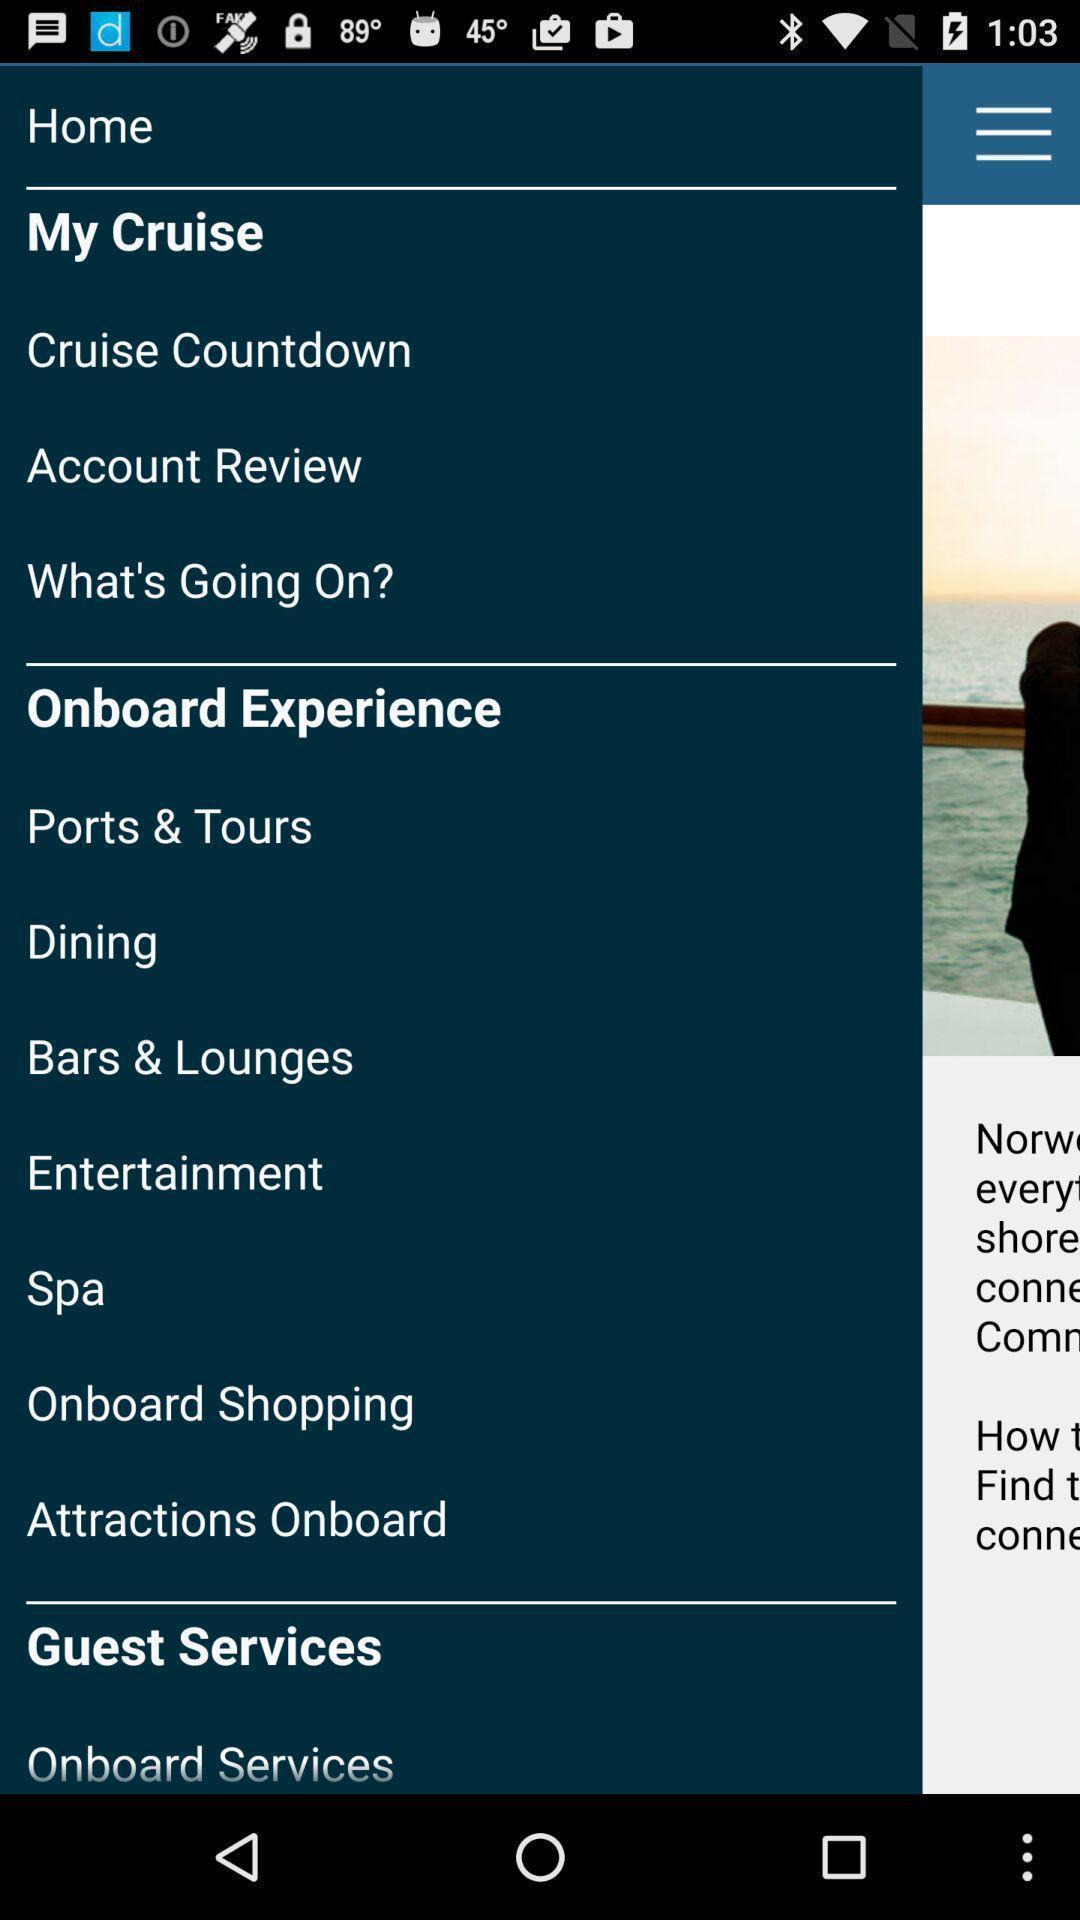What is the overall content of this screenshot? Page displaying the various options. 